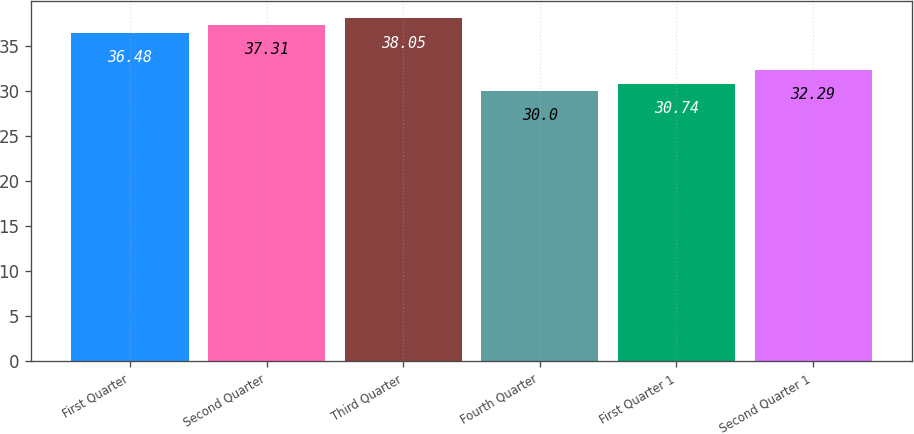<chart> <loc_0><loc_0><loc_500><loc_500><bar_chart><fcel>First Quarter<fcel>Second Quarter<fcel>Third Quarter<fcel>Fourth Quarter<fcel>First Quarter 1<fcel>Second Quarter 1<nl><fcel>36.48<fcel>37.31<fcel>38.05<fcel>30<fcel>30.74<fcel>32.29<nl></chart> 